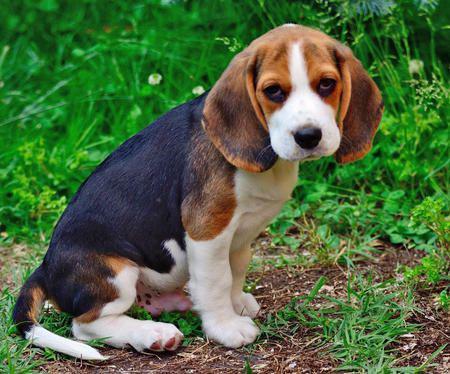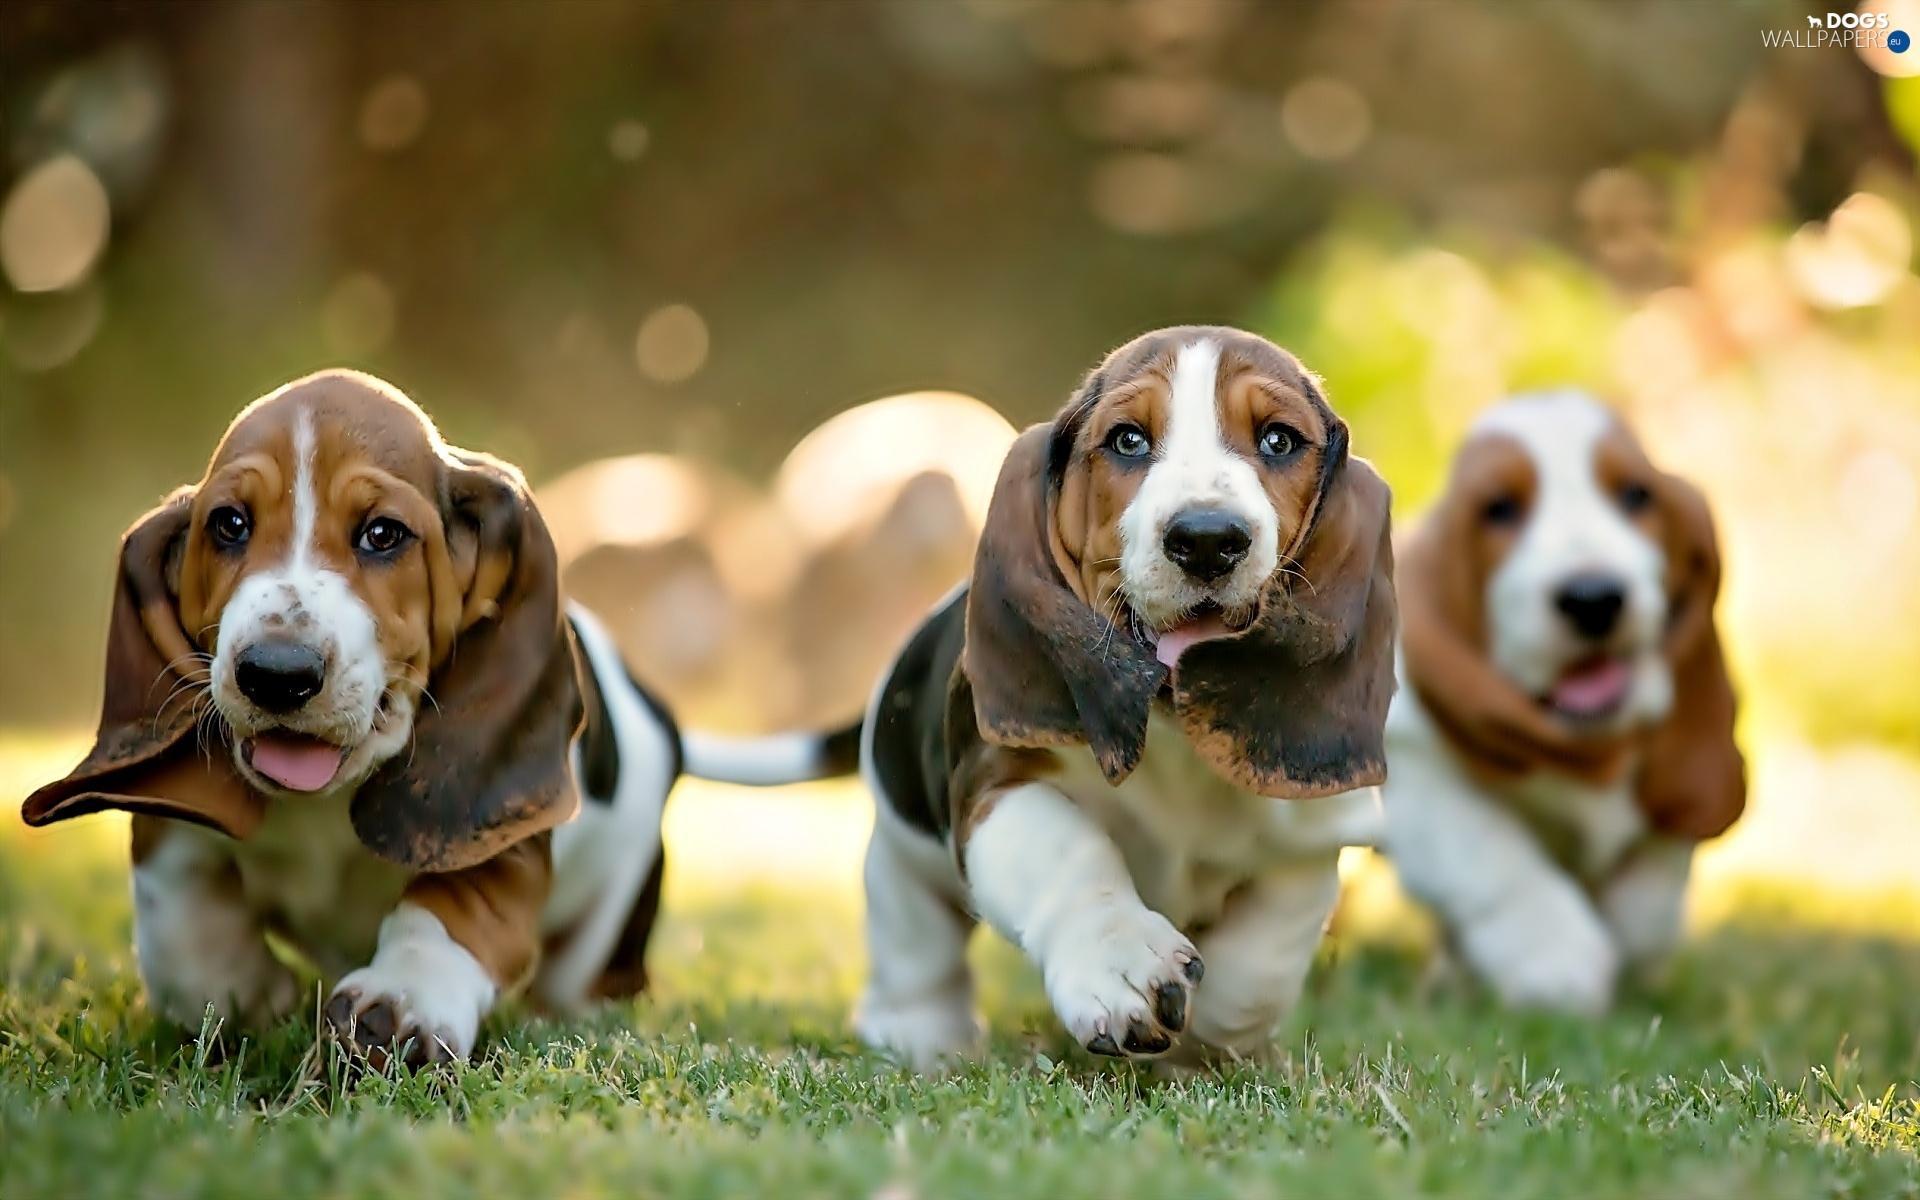The first image is the image on the left, the second image is the image on the right. Assess this claim about the two images: "There are at least 5 puppies.". Correct or not? Answer yes or no. No. 